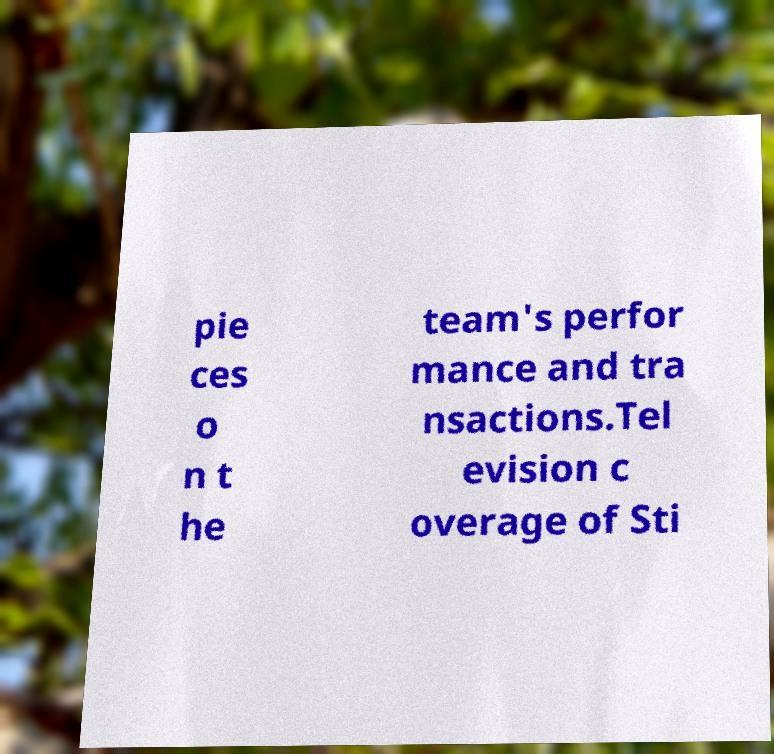There's text embedded in this image that I need extracted. Can you transcribe it verbatim? pie ces o n t he team's perfor mance and tra nsactions.Tel evision c overage of Sti 